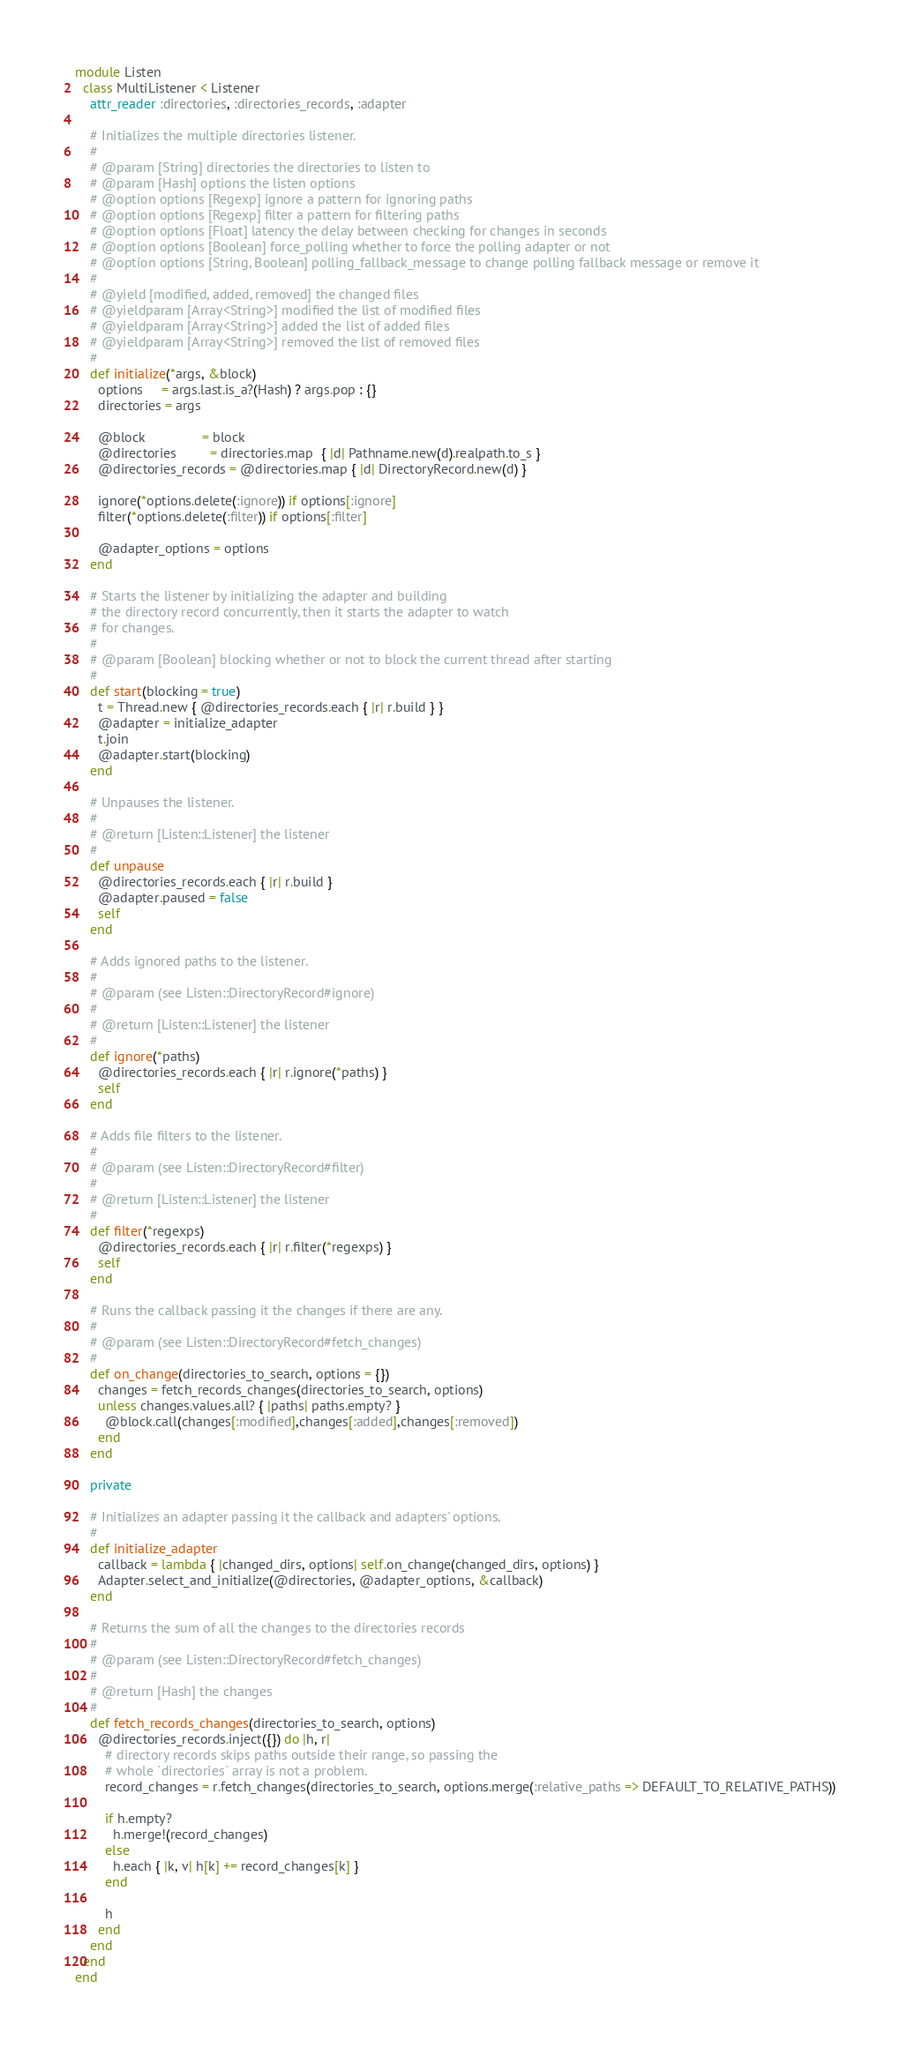<code> <loc_0><loc_0><loc_500><loc_500><_Ruby_>module Listen
  class MultiListener < Listener
    attr_reader :directories, :directories_records, :adapter

    # Initializes the multiple directories listener.
    #
    # @param [String] directories the directories to listen to
    # @param [Hash] options the listen options
    # @option options [Regexp] ignore a pattern for ignoring paths
    # @option options [Regexp] filter a pattern for filtering paths
    # @option options [Float] latency the delay between checking for changes in seconds
    # @option options [Boolean] force_polling whether to force the polling adapter or not
    # @option options [String, Boolean] polling_fallback_message to change polling fallback message or remove it
    #
    # @yield [modified, added, removed] the changed files
    # @yieldparam [Array<String>] modified the list of modified files
    # @yieldparam [Array<String>] added the list of added files
    # @yieldparam [Array<String>] removed the list of removed files
    #
    def initialize(*args, &block)
      options     = args.last.is_a?(Hash) ? args.pop : {}
      directories = args

      @block               = block
      @directories         = directories.map  { |d| Pathname.new(d).realpath.to_s }
      @directories_records = @directories.map { |d| DirectoryRecord.new(d) }

      ignore(*options.delete(:ignore)) if options[:ignore]
      filter(*options.delete(:filter)) if options[:filter]

      @adapter_options = options
    end

    # Starts the listener by initializing the adapter and building
    # the directory record concurrently, then it starts the adapter to watch
    # for changes.
    #
    # @param [Boolean] blocking whether or not to block the current thread after starting
    #
    def start(blocking = true)
      t = Thread.new { @directories_records.each { |r| r.build } }
      @adapter = initialize_adapter
      t.join
      @adapter.start(blocking)
    end

    # Unpauses the listener.
    #
    # @return [Listen::Listener] the listener
    #
    def unpause
      @directories_records.each { |r| r.build }
      @adapter.paused = false
      self
    end

    # Adds ignored paths to the listener.
    #
    # @param (see Listen::DirectoryRecord#ignore)
    #
    # @return [Listen::Listener] the listener
    #
    def ignore(*paths)
      @directories_records.each { |r| r.ignore(*paths) }
      self
    end

    # Adds file filters to the listener.
    #
    # @param (see Listen::DirectoryRecord#filter)
    #
    # @return [Listen::Listener] the listener
    #
    def filter(*regexps)
      @directories_records.each { |r| r.filter(*regexps) }
      self
    end

    # Runs the callback passing it the changes if there are any.
    #
    # @param (see Listen::DirectoryRecord#fetch_changes)
    #
    def on_change(directories_to_search, options = {})
      changes = fetch_records_changes(directories_to_search, options)
      unless changes.values.all? { |paths| paths.empty? }
        @block.call(changes[:modified],changes[:added],changes[:removed])
      end
    end

    private

    # Initializes an adapter passing it the callback and adapters' options.
    #
    def initialize_adapter
      callback = lambda { |changed_dirs, options| self.on_change(changed_dirs, options) }
      Adapter.select_and_initialize(@directories, @adapter_options, &callback)
    end

    # Returns the sum of all the changes to the directories records
    #
    # @param (see Listen::DirectoryRecord#fetch_changes)
    #
    # @return [Hash] the changes
    #
    def fetch_records_changes(directories_to_search, options)
      @directories_records.inject({}) do |h, r|
        # directory records skips paths outside their range, so passing the
        # whole `directories` array is not a problem.
        record_changes = r.fetch_changes(directories_to_search, options.merge(:relative_paths => DEFAULT_TO_RELATIVE_PATHS))

        if h.empty?
          h.merge!(record_changes)
        else
          h.each { |k, v| h[k] += record_changes[k] }
        end

        h
      end
    end
  end
end
</code> 